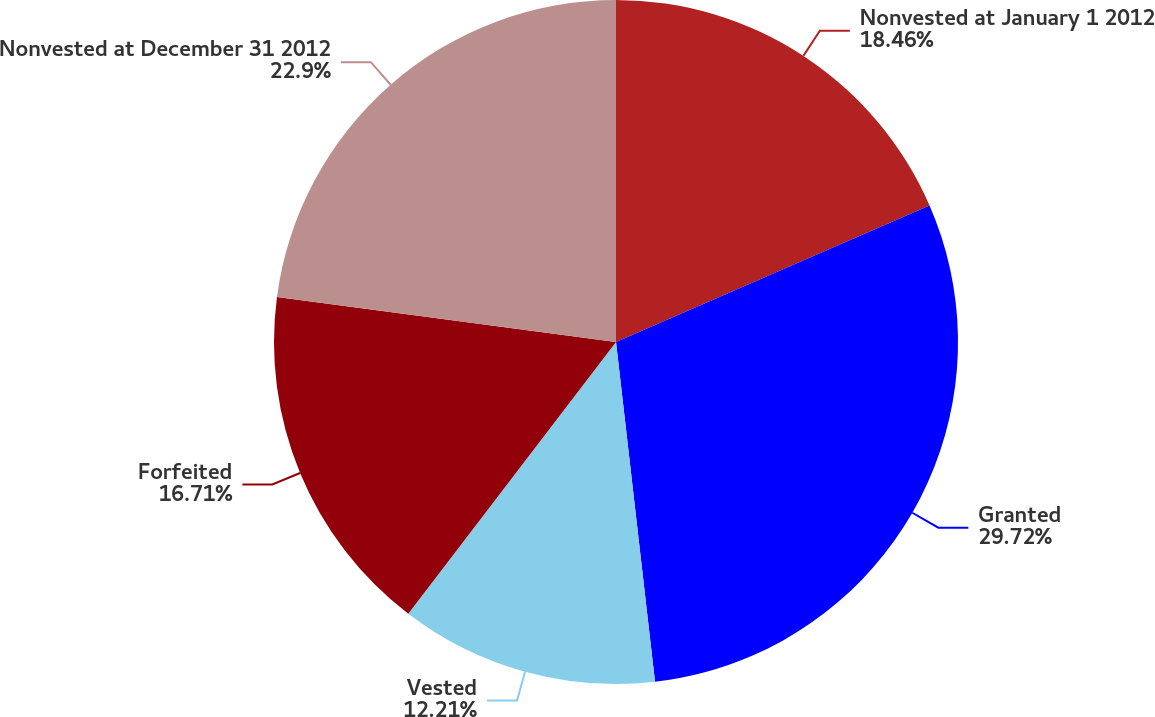Convert chart to OTSL. <chart><loc_0><loc_0><loc_500><loc_500><pie_chart><fcel>Nonvested at January 1 2012<fcel>Granted<fcel>Vested<fcel>Forfeited<fcel>Nonvested at December 31 2012<nl><fcel>18.46%<fcel>29.72%<fcel>12.21%<fcel>16.71%<fcel>22.9%<nl></chart> 